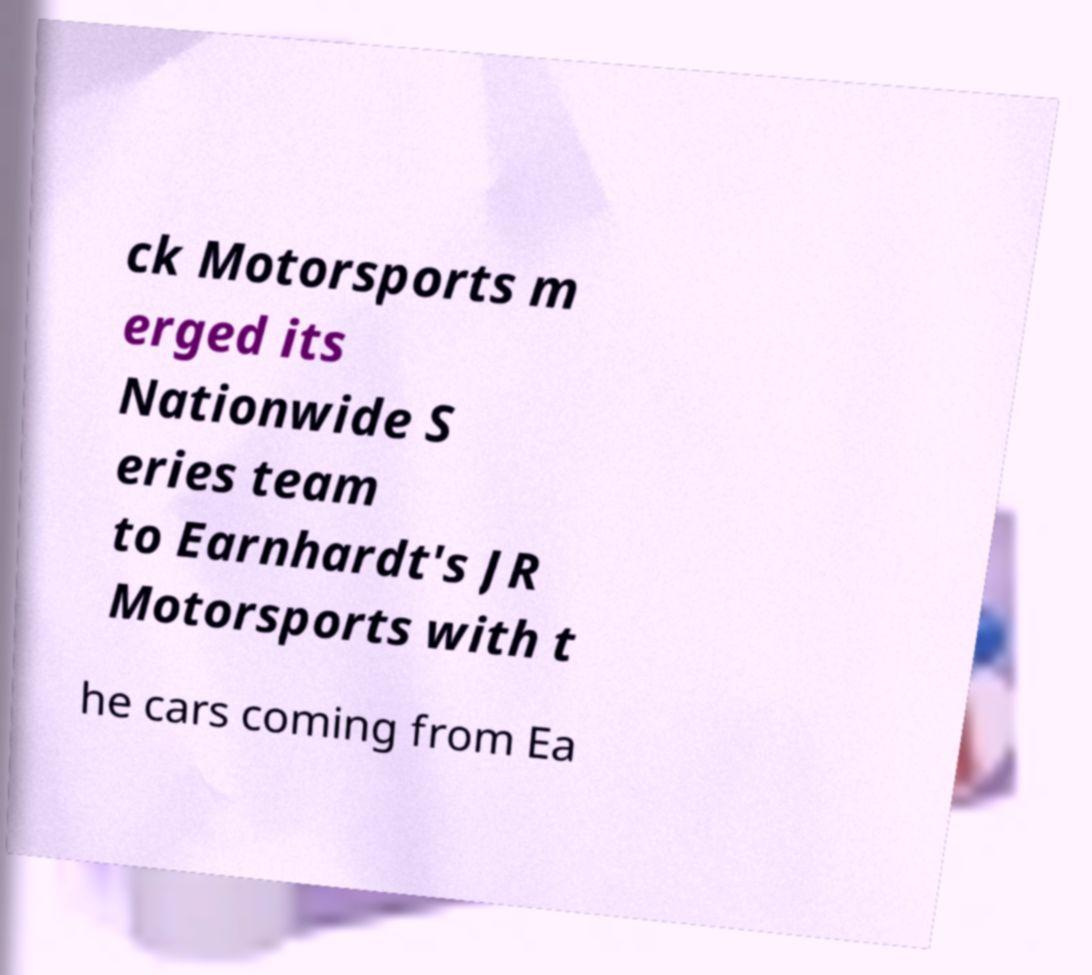What messages or text are displayed in this image? I need them in a readable, typed format. ck Motorsports m erged its Nationwide S eries team to Earnhardt's JR Motorsports with t he cars coming from Ea 